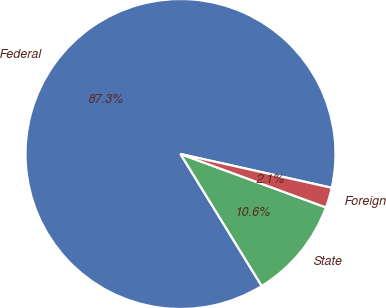Convert chart to OTSL. <chart><loc_0><loc_0><loc_500><loc_500><pie_chart><fcel>Federal<fcel>State<fcel>Foreign<nl><fcel>87.28%<fcel>10.62%<fcel>2.1%<nl></chart> 